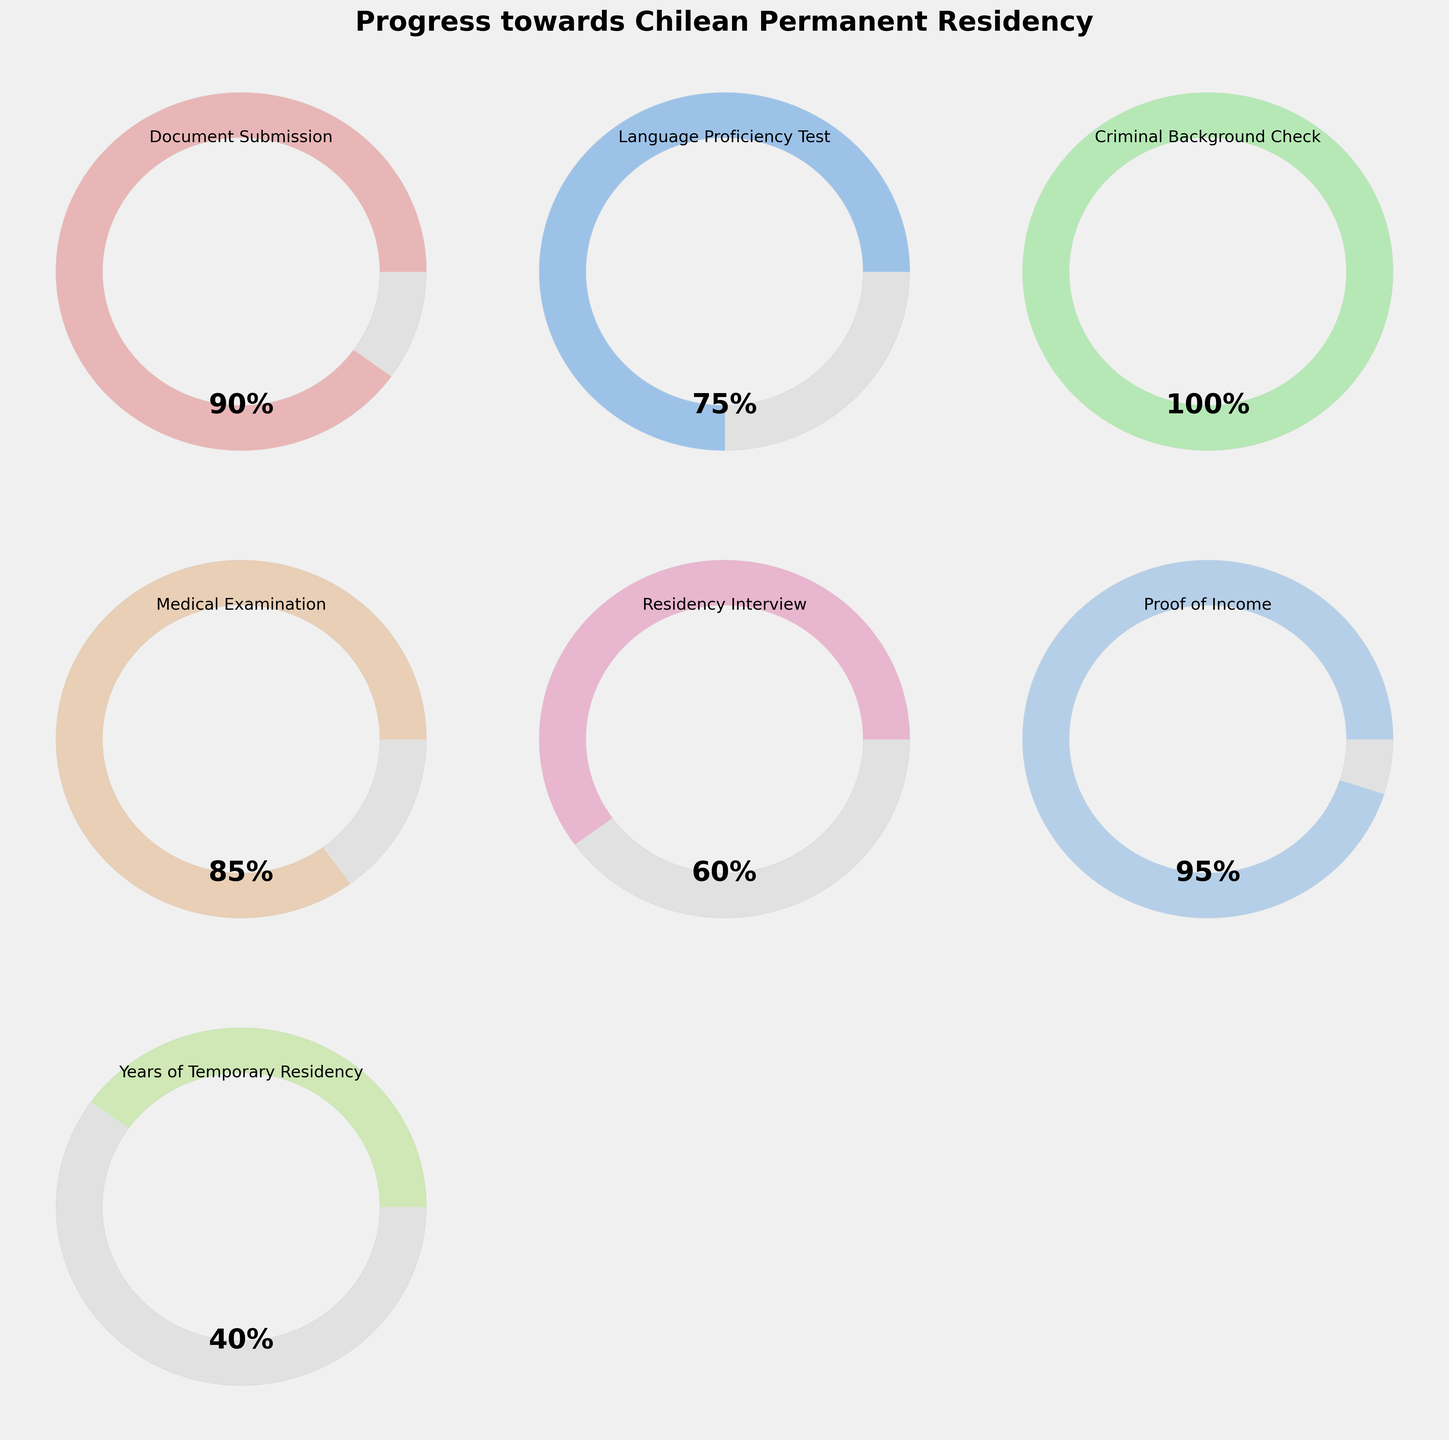Which step shows the highest progress? To find the highest progress, look at the percentage values for each step. The step with the largest percentage is the one with the highest progress.
Answer: Criminal Background Check What is the progress percentage for the Residency Interview step? Look at the gauge chart for the "Residency Interview" step and read the percentage value displayed.
Answer: 60% How many steps have a progress percentage of 90% or higher? Identify and count the steps with progress values equal to or greater than 90%.
Answer: 4 Which step has the lowest progress? Identify the step with the smallest percentage value displayed on the gauge charts.
Answer: Years of Temporary Residency What is the average progress across all steps? Sum all the progress percentages and divide by the total number of steps (7). (90 + 75 + 100 + 85 + 60 + 95 + 40) / 7 = 545 / 7 ≈ 77.86
Answer: ~77.86% How much more progress is needed to reach 100% in Medical Examination? Subtract the current progress value for Medical Examination from 100%. 100% - 85% = 15%
Answer: 15% Which steps have a progress percentage between 70% and 100%? Identify the steps with progress values in the range of 70% to 100%.
Answer: Document Submission, Language Proficiency Test, Criminal Background Check, Medical Examination, Proof of Income What is the cumulative progress of Document Submission and Proof of Income? Add the progress values of "Document Submission" and "Proof of Income". 90% + 95% = 185%
Answer: 185% Which step needs more than 50% progress to reach completion? Identify the steps that have less than 50% progress and determine by how much more progress is needed to reach 100%.
Answer: Years of Temporary Residency If the average progress required to pass each step is 80%, how many steps are currently below this average? Count the number of steps with progress percentages less than 80%.
Answer: 3 